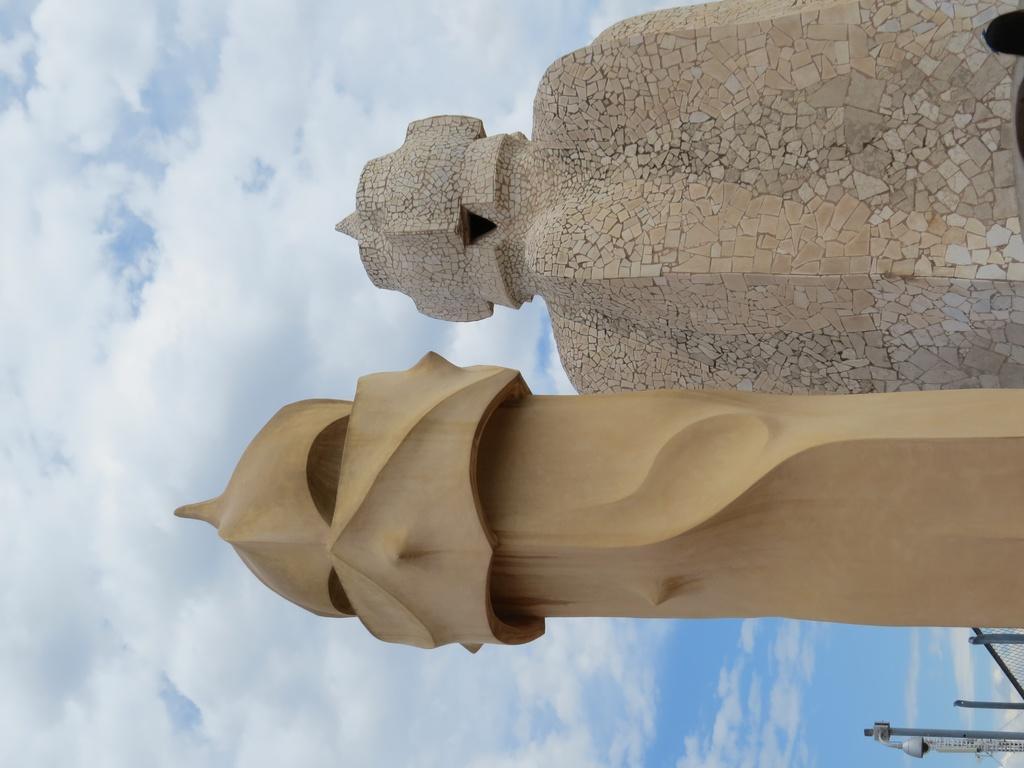Could you give a brief overview of what you see in this image? In this image we can see monuments and We can see sky and clouds. 